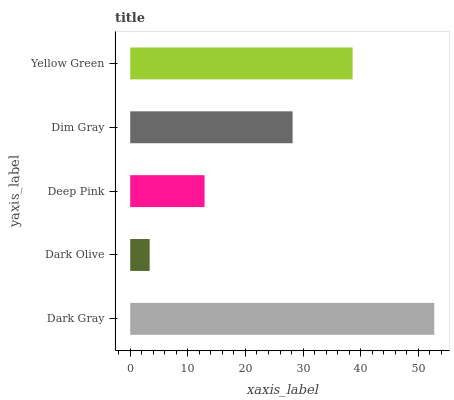Is Dark Olive the minimum?
Answer yes or no. Yes. Is Dark Gray the maximum?
Answer yes or no. Yes. Is Deep Pink the minimum?
Answer yes or no. No. Is Deep Pink the maximum?
Answer yes or no. No. Is Deep Pink greater than Dark Olive?
Answer yes or no. Yes. Is Dark Olive less than Deep Pink?
Answer yes or no. Yes. Is Dark Olive greater than Deep Pink?
Answer yes or no. No. Is Deep Pink less than Dark Olive?
Answer yes or no. No. Is Dim Gray the high median?
Answer yes or no. Yes. Is Dim Gray the low median?
Answer yes or no. Yes. Is Dark Gray the high median?
Answer yes or no. No. Is Yellow Green the low median?
Answer yes or no. No. 